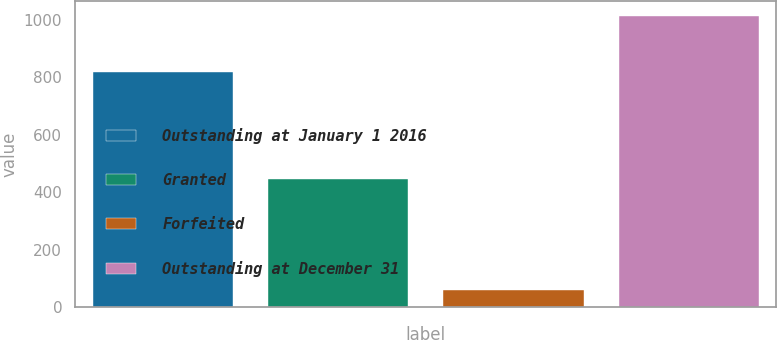<chart> <loc_0><loc_0><loc_500><loc_500><bar_chart><fcel>Outstanding at January 1 2016<fcel>Granted<fcel>Forfeited<fcel>Outstanding at December 31<nl><fcel>820<fcel>447<fcel>59<fcel>1015<nl></chart> 